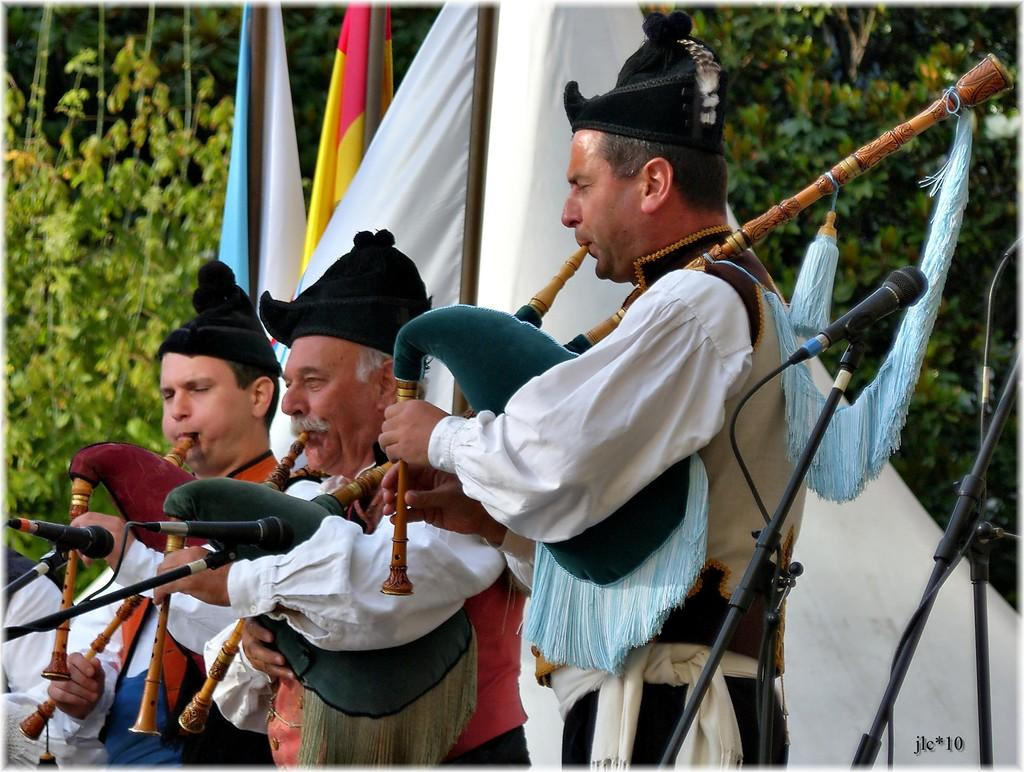What are the people in the image doing? The people in the image are playing musical instruments. What is located in front of the people playing musical instruments? There are mice in front of the people playing musical instruments. What else can be seen in the image besides the people and mice? There are flags and trees in the image. What type of fuel is being used by the band in the image? There is no band present in the image, and therefore no fuel is being used. How many beds can be seen in the image? There are no beds present in the image. 